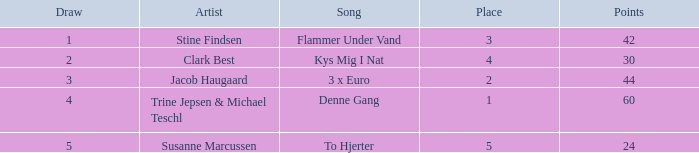What is the draw containing points more than 44 and a spot bigger than 1? None. 